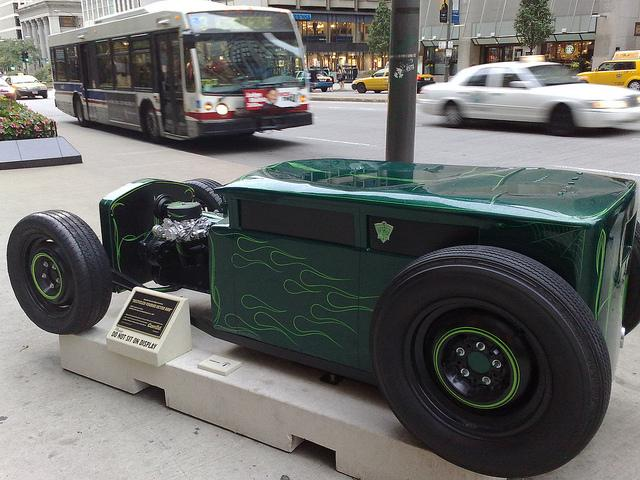Why is the car on the sidewalk? Please explain your reasoning. display. This vehicle is not functional and there is a plaque explaining itself so it would be considered a decoration. 